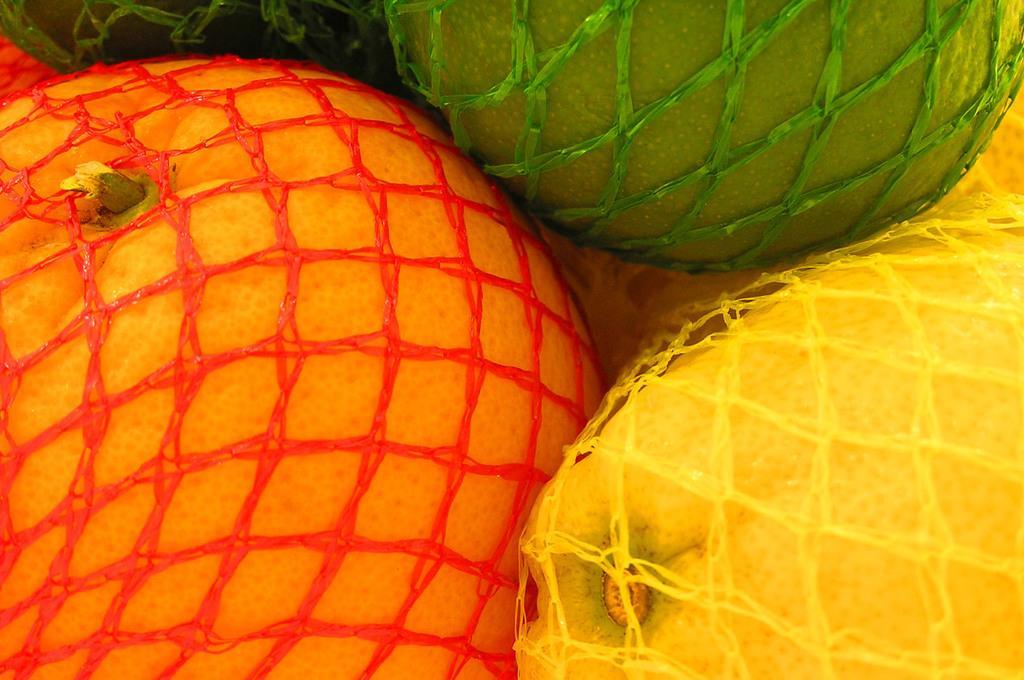In one or two sentences, can you explain what this image depicts? There is a fruit which is covered with red color net beside other fruit which is covered yellow color net. Which is near other fruit which is covered with green color net. In the background, there are other fruits covered with different color nets. 